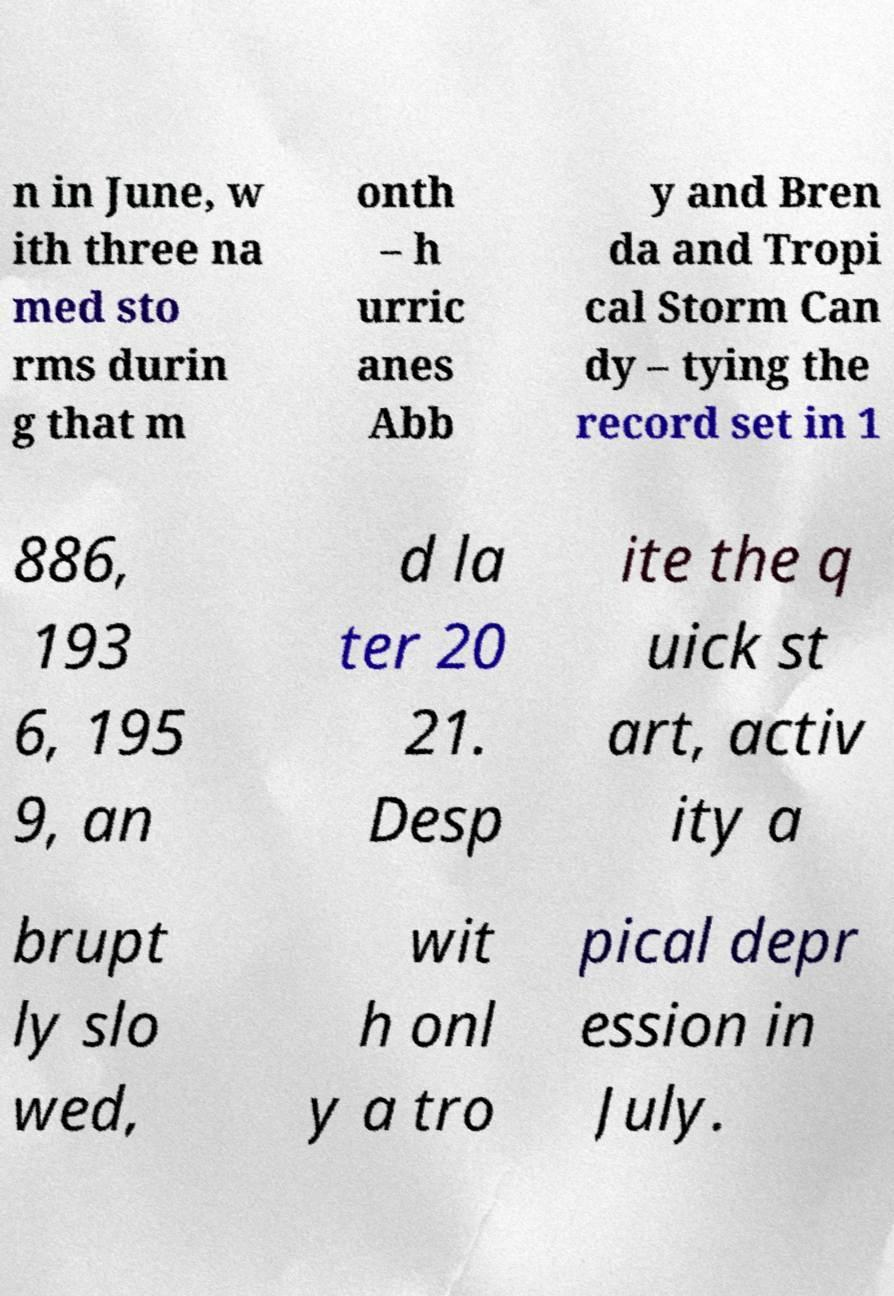Please identify and transcribe the text found in this image. n in June, w ith three na med sto rms durin g that m onth – h urric anes Abb y and Bren da and Tropi cal Storm Can dy – tying the record set in 1 886, 193 6, 195 9, an d la ter 20 21. Desp ite the q uick st art, activ ity a brupt ly slo wed, wit h onl y a tro pical depr ession in July. 